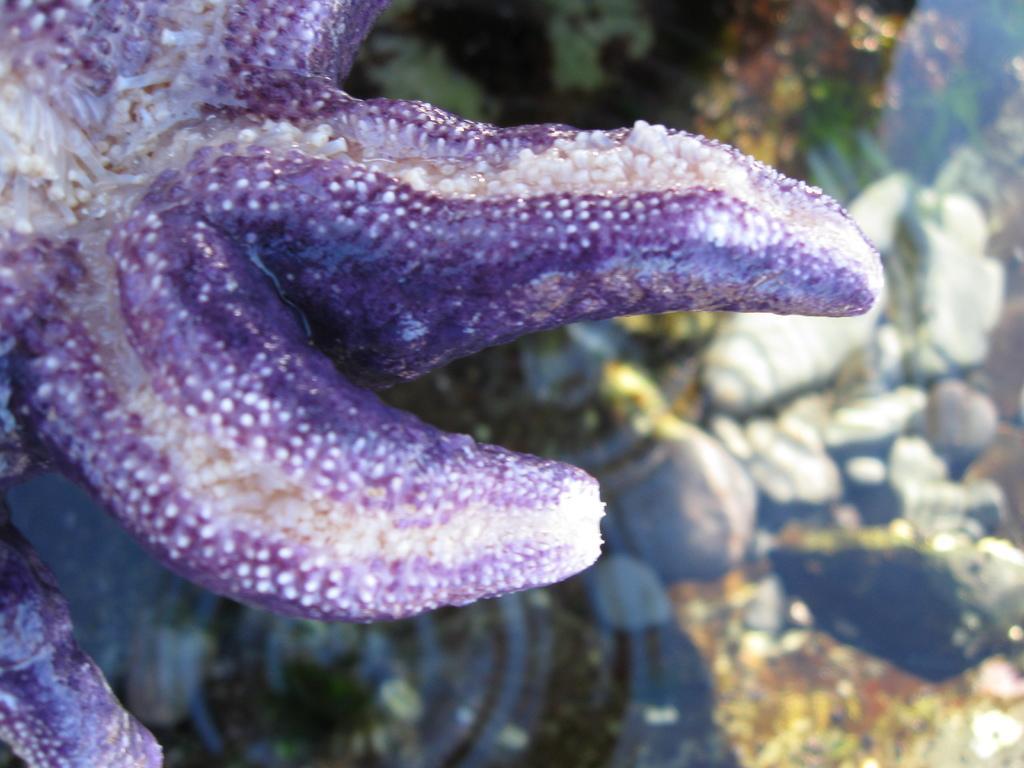Could you give a brief overview of what you see in this image? In this image, we can see a starfish. We can also see some objects. 